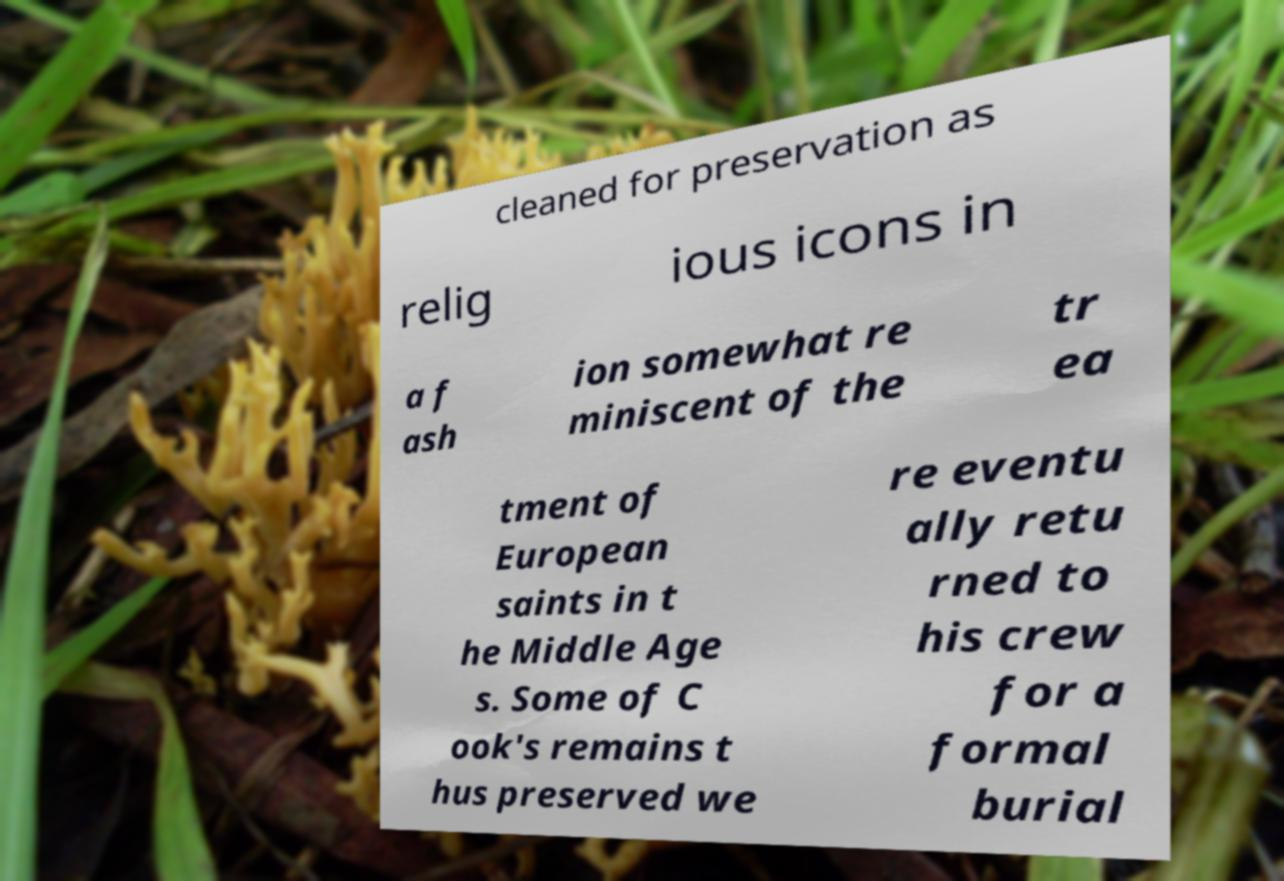Could you assist in decoding the text presented in this image and type it out clearly? cleaned for preservation as relig ious icons in a f ash ion somewhat re miniscent of the tr ea tment of European saints in t he Middle Age s. Some of C ook's remains t hus preserved we re eventu ally retu rned to his crew for a formal burial 